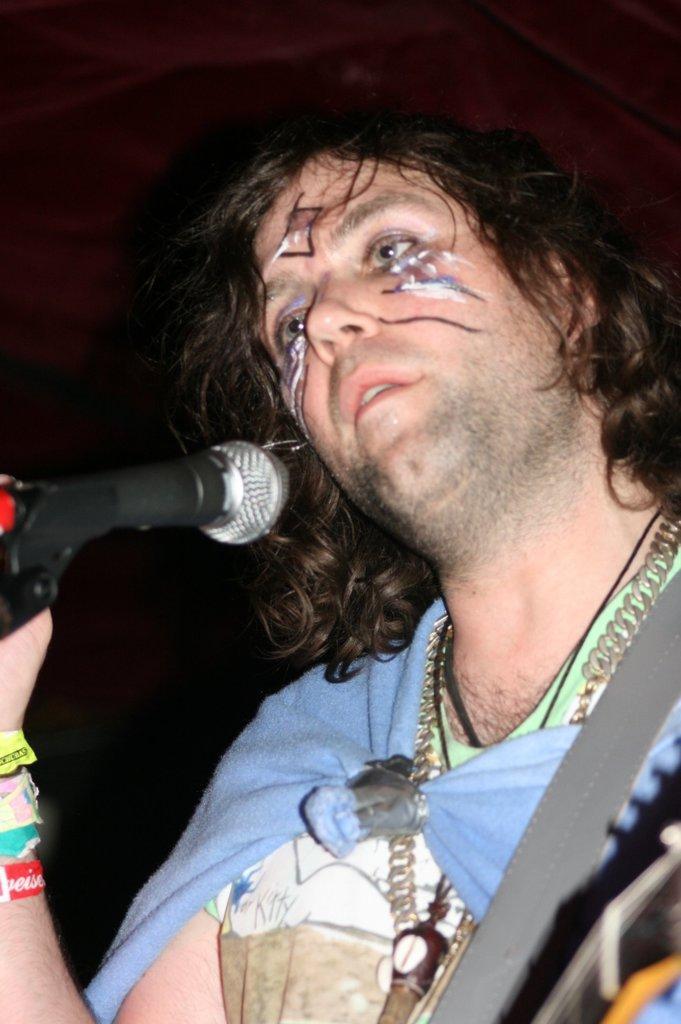Can you describe this image briefly? In the picture we can see a man holding a microphone, in the background we can see a red wall and a chair. 